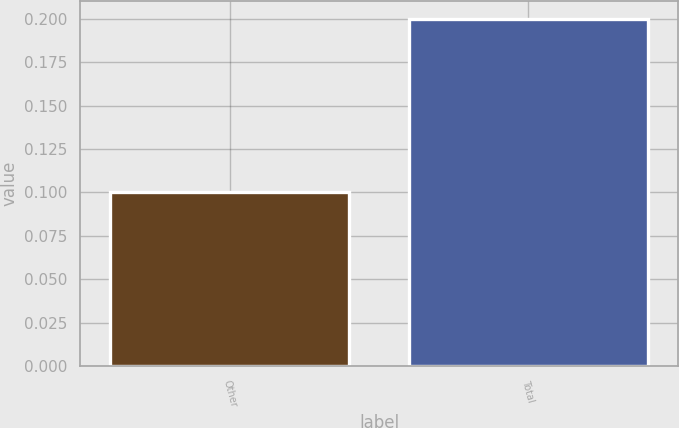<chart> <loc_0><loc_0><loc_500><loc_500><bar_chart><fcel>Other<fcel>Total<nl><fcel>0.1<fcel>0.2<nl></chart> 